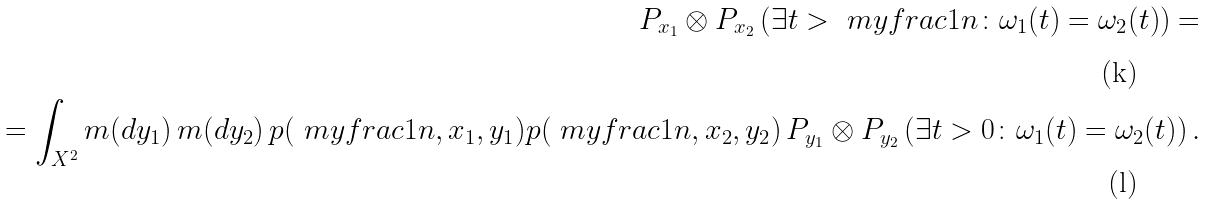Convert formula to latex. <formula><loc_0><loc_0><loc_500><loc_500>P _ { x _ { 1 } } \otimes P _ { x _ { 2 } } \left ( \exists t > \ m y f r a c 1 n \colon \omega _ { 1 } ( t ) = \omega _ { 2 } ( t ) \right ) = \\ = \int _ { X ^ { 2 } } m ( d y _ { 1 } ) \, m ( d y _ { 2 } ) \, p ( \ m y f r a c 1 n , x _ { 1 } , y _ { 1 } ) p ( \ m y f r a c 1 n , x _ { 2 } , y _ { 2 } ) \, P _ { y _ { 1 } } \otimes P _ { y _ { 2 } } \left ( \exists t > 0 \colon \omega _ { 1 } ( t ) = \omega _ { 2 } ( t ) \right ) .</formula> 